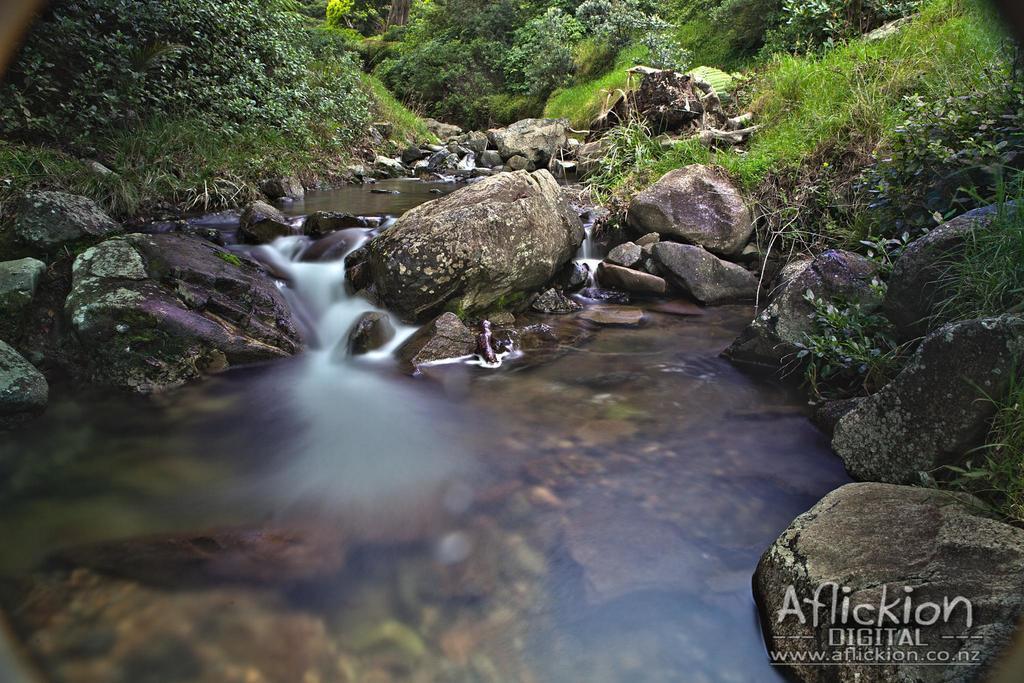Can you describe this image briefly? In this image, we can see water, there are some stones, we can see some green color plants. 